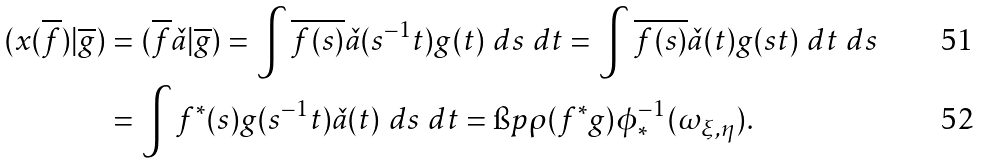<formula> <loc_0><loc_0><loc_500><loc_500>( x ( \overline { f } ) | \overline { g } ) & = ( \overline { f } \check { a } | \overline { g } ) = \int \overline { f ( s ) } \check { a } ( s ^ { - 1 } t ) g ( t ) \ d s \ d t = \int \overline { f ( s ) } \check { a } ( t ) g ( s t ) \ d t \ d s \\ & = \int f ^ { * } ( s ) g ( s ^ { - 1 } t ) \check { a } ( t ) \ d s \ d t = \i p { \rho ( f ^ { * } g ) } { \phi _ { * } ^ { - 1 } ( \omega _ { \xi , \eta } ) } .</formula> 